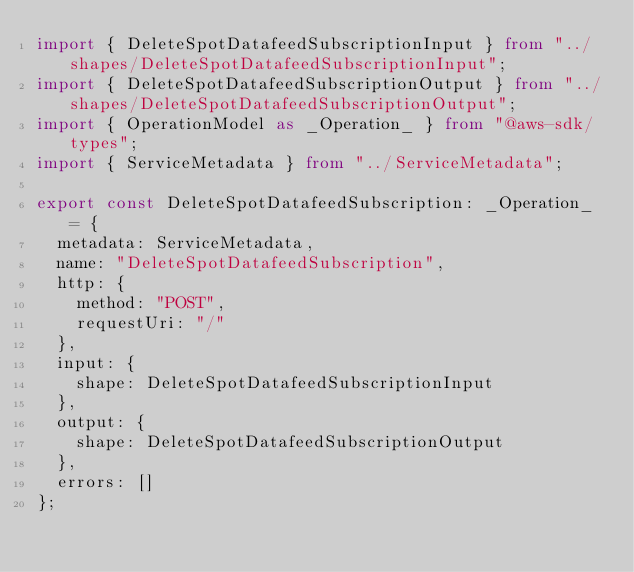<code> <loc_0><loc_0><loc_500><loc_500><_TypeScript_>import { DeleteSpotDatafeedSubscriptionInput } from "../shapes/DeleteSpotDatafeedSubscriptionInput";
import { DeleteSpotDatafeedSubscriptionOutput } from "../shapes/DeleteSpotDatafeedSubscriptionOutput";
import { OperationModel as _Operation_ } from "@aws-sdk/types";
import { ServiceMetadata } from "../ServiceMetadata";

export const DeleteSpotDatafeedSubscription: _Operation_ = {
  metadata: ServiceMetadata,
  name: "DeleteSpotDatafeedSubscription",
  http: {
    method: "POST",
    requestUri: "/"
  },
  input: {
    shape: DeleteSpotDatafeedSubscriptionInput
  },
  output: {
    shape: DeleteSpotDatafeedSubscriptionOutput
  },
  errors: []
};
</code> 